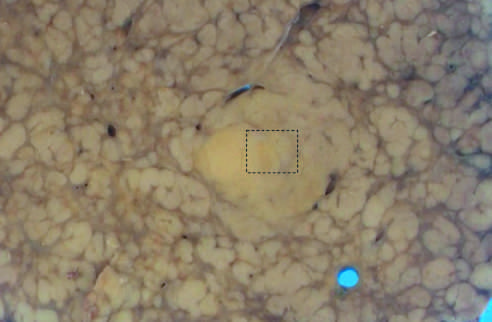what does nodule-in-nodule growth suggest?
Answer the question using a single word or phrase. An evolving cancer 